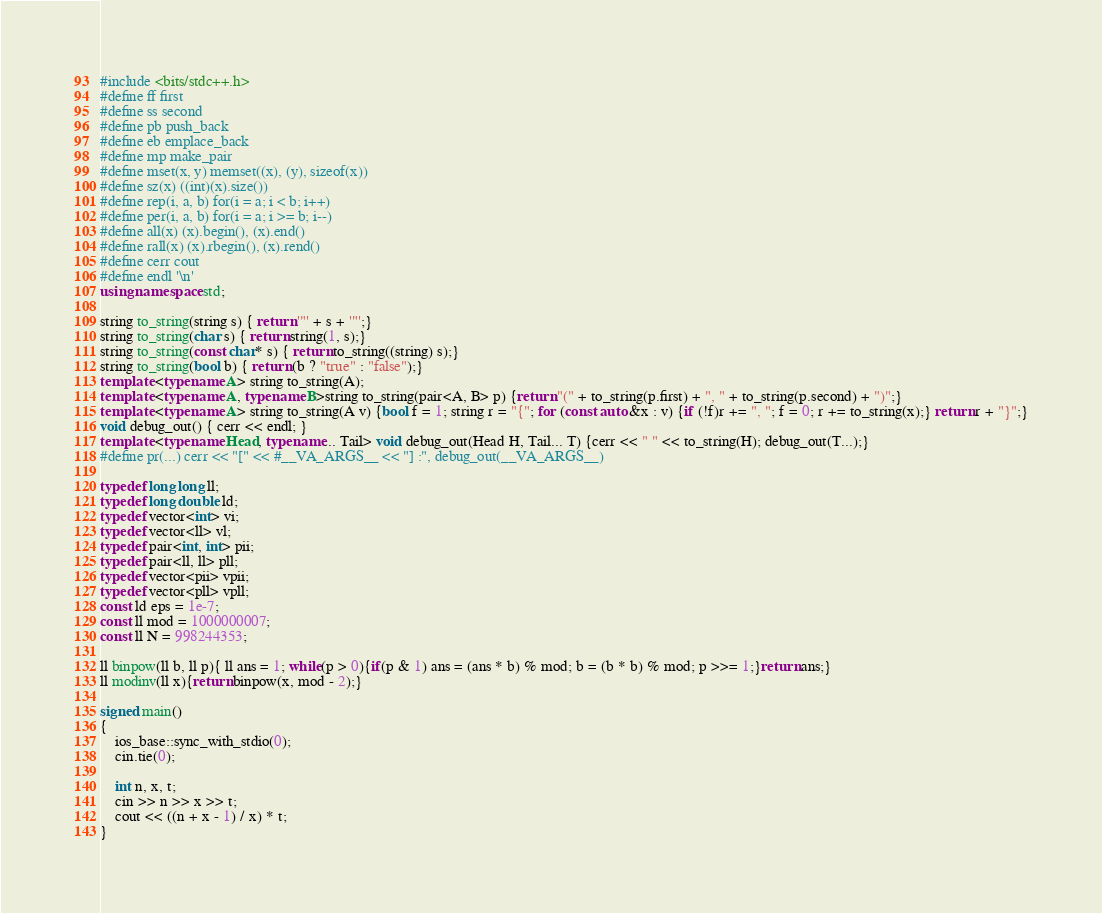Convert code to text. <code><loc_0><loc_0><loc_500><loc_500><_C++_>#include <bits/stdc++.h>
#define ff first
#define ss second
#define pb push_back
#define eb emplace_back
#define mp make_pair
#define mset(x, y) memset((x), (y), sizeof(x))
#define sz(x) ((int)(x).size())
#define rep(i, a, b) for(i = a; i < b; i++)
#define per(i, a, b) for(i = a; i >= b; i--)
#define all(x) (x).begin(), (x).end()
#define rall(x) (x).rbegin(), (x).rend()
#define cerr cout
#define endl '\n'
using namespace std;

string to_string(string s) { return '"' + s + '"';}
string to_string(char s) { return string(1, s);}
string to_string(const char* s) { return to_string((string) s);}
string to_string(bool b) { return (b ? "true" : "false");}
template <typename A> string to_string(A);
template <typename A, typename B>string to_string(pair<A, B> p) {return "(" + to_string(p.first) + ", " + to_string(p.second) + ")";}
template <typename A> string to_string(A v) {bool f = 1; string r = "{"; for (const auto &x : v) {if (!f)r += ", "; f = 0; r += to_string(x);} return r + "}";}
void debug_out() { cerr << endl; }
template <typename Head, typename... Tail> void debug_out(Head H, Tail... T) {cerr << " " << to_string(H); debug_out(T...);}
#define pr(...) cerr << "[" << #__VA_ARGS__ << "] :", debug_out(__VA_ARGS__)

typedef long long ll;
typedef long double ld;
typedef vector<int> vi;
typedef vector<ll> vl;
typedef pair<int, int> pii;
typedef pair<ll, ll> pll;
typedef vector<pii> vpii;
typedef vector<pll> vpll;
const ld eps = 1e-7;
const ll mod = 1000000007;
const ll N = 998244353;

ll binpow(ll b, ll p){ ll ans = 1; while(p > 0){if(p & 1) ans = (ans * b) % mod; b = (b * b) % mod; p >>= 1;}return ans;}
ll modinv(ll x){return binpow(x, mod - 2);}

signed main()
{
	ios_base::sync_with_stdio(0);
	cin.tie(0);

	int n, x, t;
	cin >> n >> x >> t;
	cout << ((n + x - 1) / x) * t;
}</code> 